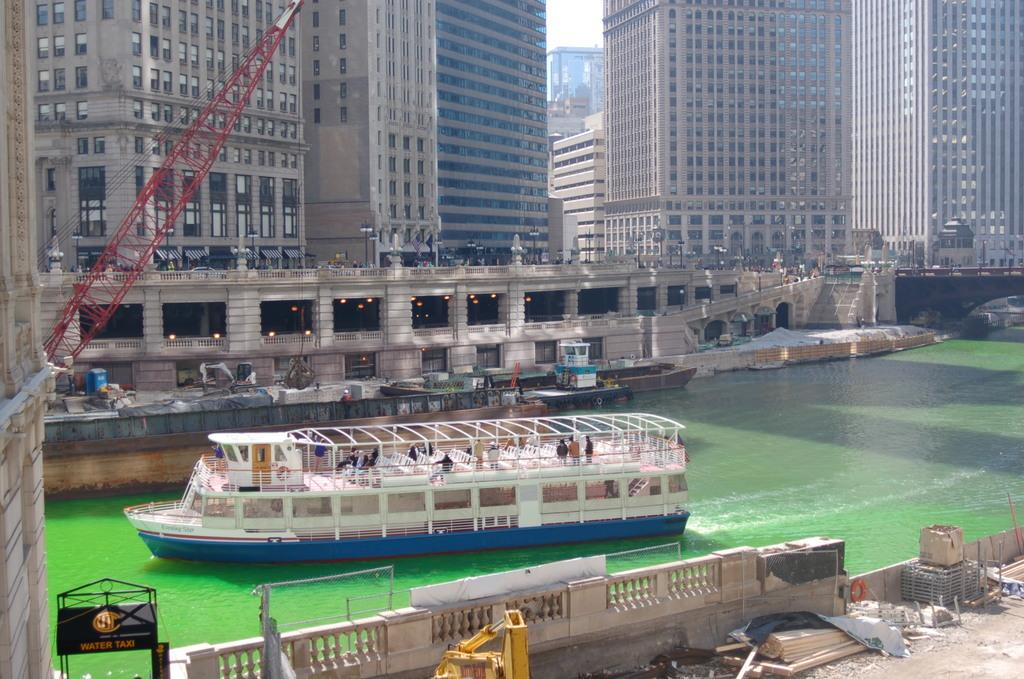What is the main subject in the center of the image? There is a ship in the center of the image. What is the ship doing in the image? The ship is sailing on the water. What feature can be seen at the front of the ship? There is a railing in the front of the ship. What can be seen in the background of the image? There are buildings in the background of the image. What can be observed in terms of lighting in the image? There are lights visible in the image. How many dogs are playing with the hose in the image? There are no dogs or hoses present in the image; it features a ship sailing on the water with a railing and buildings in the background. 